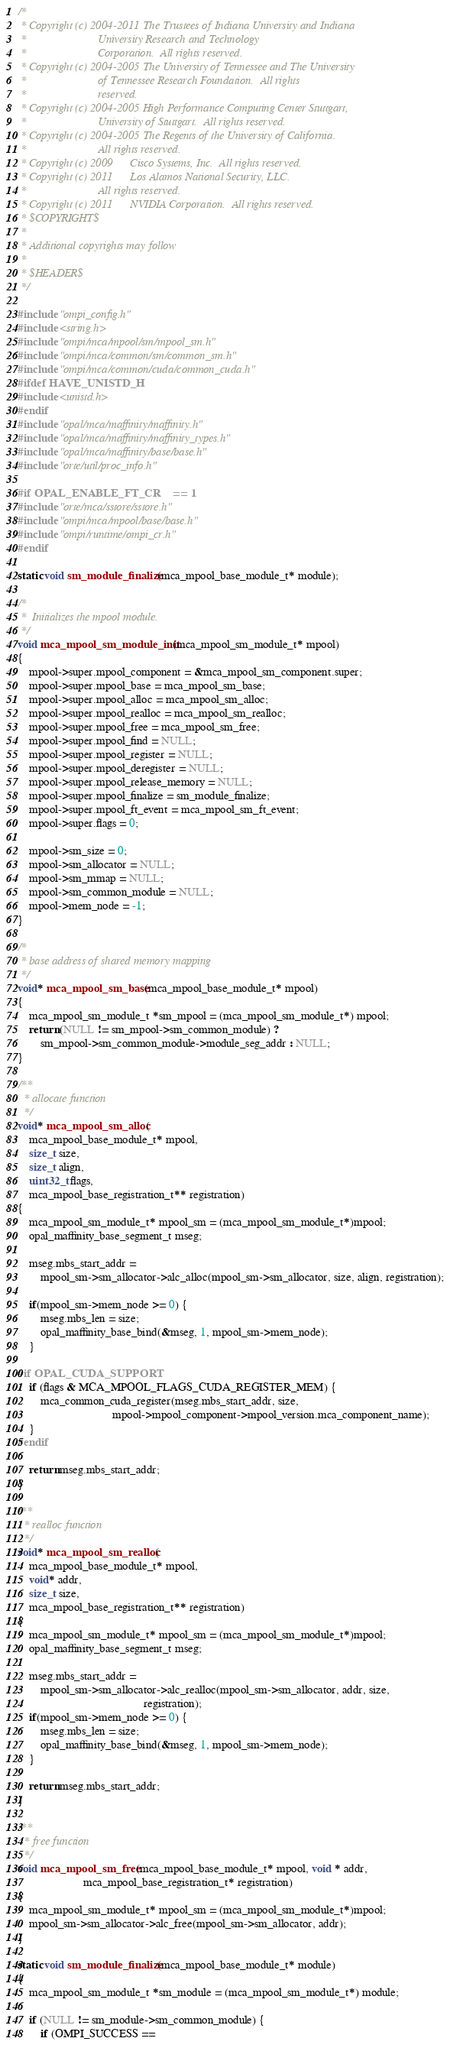Convert code to text. <code><loc_0><loc_0><loc_500><loc_500><_C_>/*
 * Copyright (c) 2004-2011 The Trustees of Indiana University and Indiana
 *                         University Research and Technology
 *                         Corporation.  All rights reserved.
 * Copyright (c) 2004-2005 The University of Tennessee and The University
 *                         of Tennessee Research Foundation.  All rights
 *                         reserved.
 * Copyright (c) 2004-2005 High Performance Computing Center Stuttgart, 
 *                         University of Stuttgart.  All rights reserved.
 * Copyright (c) 2004-2005 The Regents of the University of California.
 *                         All rights reserved.
 * Copyright (c) 2009      Cisco Systems, Inc.  All rights reserved.
 * Copyright (c) 2011      Los Alamos National Security, LLC.  
 *                         All rights reserved. 
 * Copyright (c) 2011      NVIDIA Corporation.  All rights reserved.
 * $COPYRIGHT$
 * 
 * Additional copyrights may follow
 * 
 * $HEADER$
 */

#include "ompi_config.h"
#include <string.h>
#include "ompi/mca/mpool/sm/mpool_sm.h"
#include "ompi/mca/common/sm/common_sm.h"
#include "ompi/mca/common/cuda/common_cuda.h"
#ifdef HAVE_UNISTD_H
#include <unistd.h>
#endif
#include "opal/mca/maffinity/maffinity.h"
#include "opal/mca/maffinity/maffinity_types.h"
#include "opal/mca/maffinity/base/base.h"
#include "orte/util/proc_info.h"

#if OPAL_ENABLE_FT_CR    == 1
#include "orte/mca/sstore/sstore.h"
#include "ompi/mca/mpool/base/base.h"
#include "ompi/runtime/ompi_cr.h"
#endif

static void sm_module_finalize(mca_mpool_base_module_t* module);

/* 
 *  Initializes the mpool module.
 */ 
void mca_mpool_sm_module_init(mca_mpool_sm_module_t* mpool)
{
    mpool->super.mpool_component = &mca_mpool_sm_component.super; 
    mpool->super.mpool_base = mca_mpool_sm_base; 
    mpool->super.mpool_alloc = mca_mpool_sm_alloc; 
    mpool->super.mpool_realloc = mca_mpool_sm_realloc; 
    mpool->super.mpool_free = mca_mpool_sm_free; 
    mpool->super.mpool_find = NULL; 
    mpool->super.mpool_register = NULL; 
    mpool->super.mpool_deregister = NULL; 
    mpool->super.mpool_release_memory = NULL;
    mpool->super.mpool_finalize = sm_module_finalize; 
    mpool->super.mpool_ft_event = mca_mpool_sm_ft_event;
    mpool->super.flags = 0;

    mpool->sm_size = 0;
    mpool->sm_allocator = NULL;
    mpool->sm_mmap = NULL;
    mpool->sm_common_module = NULL;
    mpool->mem_node = -1;
}

/*
 * base address of shared memory mapping
 */
void* mca_mpool_sm_base(mca_mpool_base_module_t* mpool)
{
    mca_mpool_sm_module_t *sm_mpool = (mca_mpool_sm_module_t*) mpool;
    return (NULL != sm_mpool->sm_common_module) ?
        sm_mpool->sm_common_module->module_seg_addr : NULL;
}

/**
  * allocate function
  */
void* mca_mpool_sm_alloc(
    mca_mpool_base_module_t* mpool,
    size_t size,
    size_t align,
    uint32_t flags,
    mca_mpool_base_registration_t** registration)
{
    mca_mpool_sm_module_t* mpool_sm = (mca_mpool_sm_module_t*)mpool;
    opal_maffinity_base_segment_t mseg;

    mseg.mbs_start_addr =
        mpool_sm->sm_allocator->alc_alloc(mpool_sm->sm_allocator, size, align, registration);

    if(mpool_sm->mem_node >= 0) {
        mseg.mbs_len = size;
        opal_maffinity_base_bind(&mseg, 1, mpool_sm->mem_node);
    }

#if OPAL_CUDA_SUPPORT
    if (flags & MCA_MPOOL_FLAGS_CUDA_REGISTER_MEM) {
        mca_common_cuda_register(mseg.mbs_start_addr, size,
                                 mpool->mpool_component->mpool_version.mca_component_name);
    }
#endif

    return mseg.mbs_start_addr;
}

/**
  * realloc function
  */
void* mca_mpool_sm_realloc(
    mca_mpool_base_module_t* mpool,
    void* addr,
    size_t size,
    mca_mpool_base_registration_t** registration)
{
    mca_mpool_sm_module_t* mpool_sm = (mca_mpool_sm_module_t*)mpool;
    opal_maffinity_base_segment_t mseg;

    mseg.mbs_start_addr =
        mpool_sm->sm_allocator->alc_realloc(mpool_sm->sm_allocator, addr, size,
                                            registration);
    if(mpool_sm->mem_node >= 0) {
        mseg.mbs_len = size;
        opal_maffinity_base_bind(&mseg, 1, mpool_sm->mem_node);
    }

    return mseg.mbs_start_addr;
}

/**
  * free function
  */
void mca_mpool_sm_free(mca_mpool_base_module_t* mpool, void * addr,
                       mca_mpool_base_registration_t* registration)
{
    mca_mpool_sm_module_t* mpool_sm = (mca_mpool_sm_module_t*)mpool;
    mpool_sm->sm_allocator->alc_free(mpool_sm->sm_allocator, addr);
}

static void sm_module_finalize(mca_mpool_base_module_t* module)
{
    mca_mpool_sm_module_t *sm_module = (mca_mpool_sm_module_t*) module;

    if (NULL != sm_module->sm_common_module) {
        if (OMPI_SUCCESS == </code> 